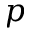<formula> <loc_0><loc_0><loc_500><loc_500>p</formula> 